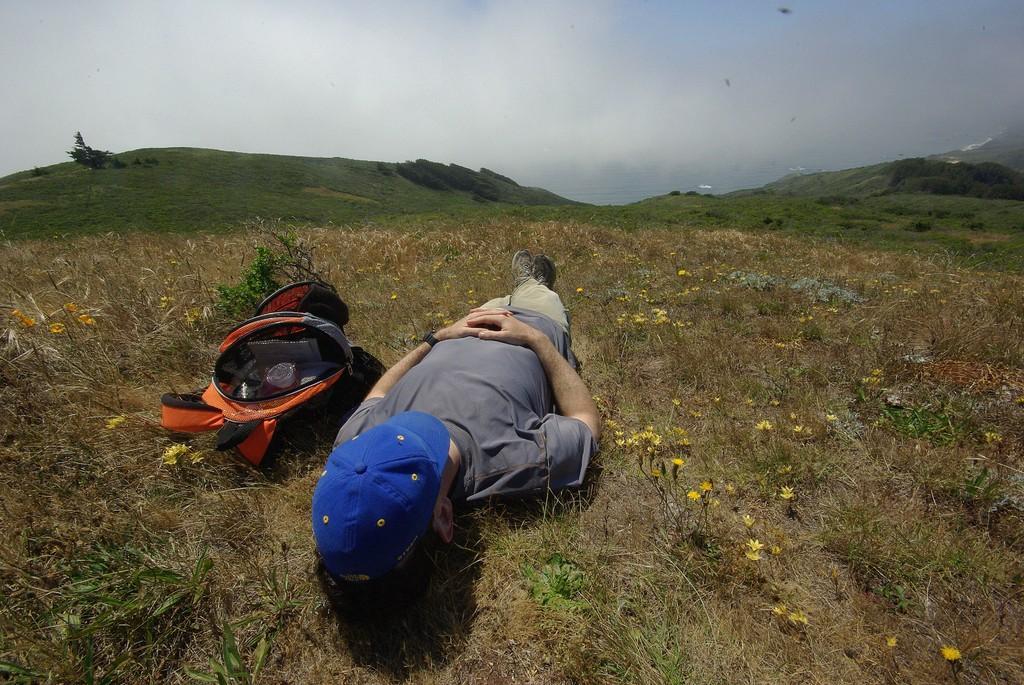Please provide a concise description of this image. In this image we can see a person lying on the ground. There is a bag beside him. In the background we can see mountains and sky. 